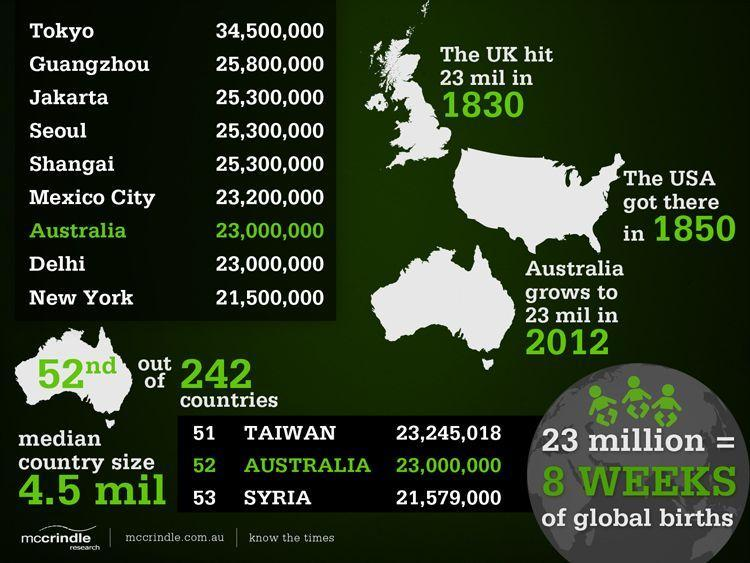What is the median country size of Australia?
Answer the question with a short phrase. 4.5 mil The country Australia is highlighted in which color- yellow, red, green, white? green What is equivalent to 23 million population as given in the info graphic? 8 weeks of global births When will Australia reach closer to 23 million population? 2012 When did UK reached 23 million population? 1830 Which country reached 23 million by 1850? USA 